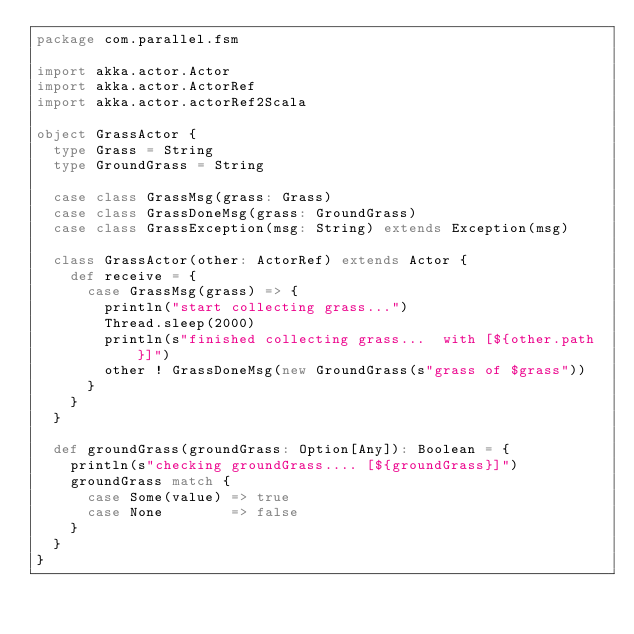Convert code to text. <code><loc_0><loc_0><loc_500><loc_500><_Scala_>package com.parallel.fsm

import akka.actor.Actor
import akka.actor.ActorRef
import akka.actor.actorRef2Scala

object GrassActor {
  type Grass = String
  type GroundGrass = String

  case class GrassMsg(grass: Grass)
  case class GrassDoneMsg(grass: GroundGrass)
  case class GrassException(msg: String) extends Exception(msg)

  class GrassActor(other: ActorRef) extends Actor {
    def receive = {
      case GrassMsg(grass) => {
        println("start collecting grass...")
        Thread.sleep(2000)
        println(s"finished collecting grass...  with [${other.path}]")
        other ! GrassDoneMsg(new GroundGrass(s"grass of $grass"))
      }
    }
  }

  def groundGrass(groundGrass: Option[Any]): Boolean = {
    println(s"checking groundGrass.... [${groundGrass}]")
    groundGrass match {
      case Some(value) => true
      case None        => false
    }
  }
}
</code> 